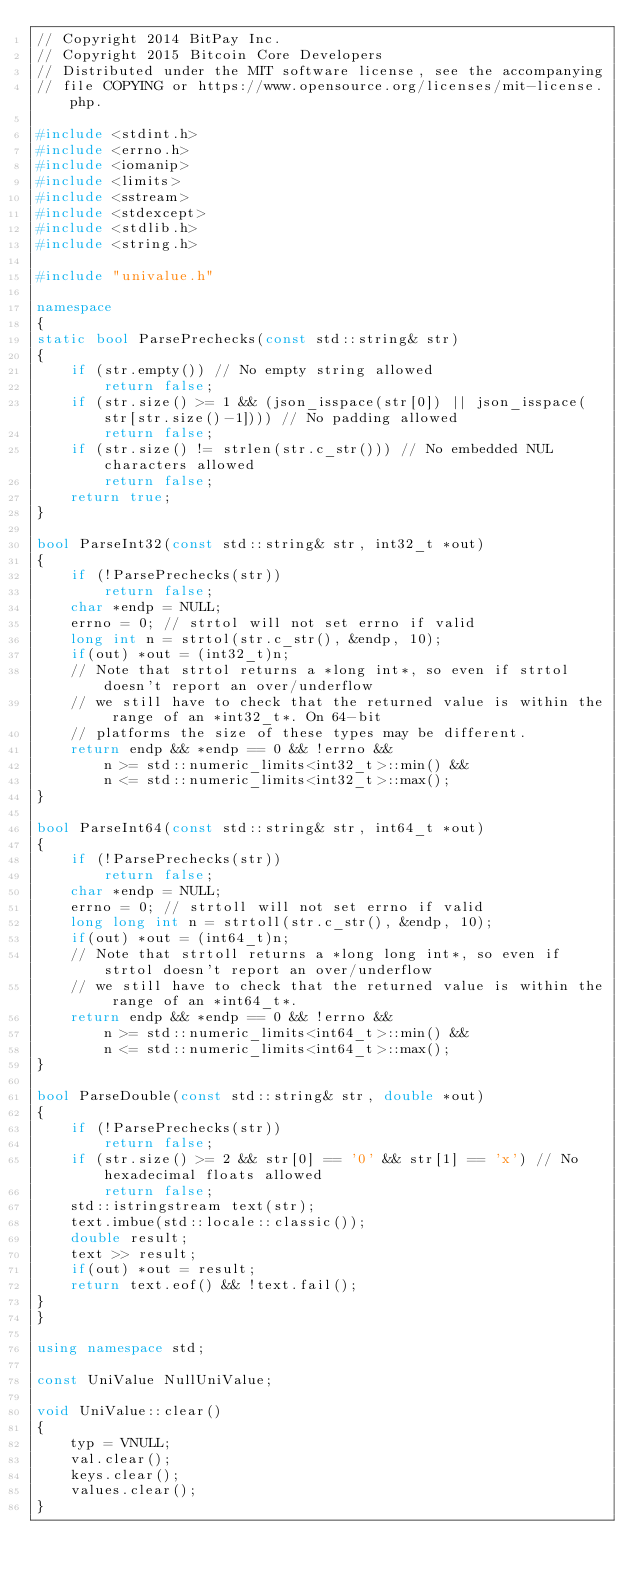<code> <loc_0><loc_0><loc_500><loc_500><_C++_>// Copyright 2014 BitPay Inc.
// Copyright 2015 Bitcoin Core Developers
// Distributed under the MIT software license, see the accompanying
// file COPYING or https://www.opensource.org/licenses/mit-license.php.

#include <stdint.h>
#include <errno.h>
#include <iomanip>
#include <limits>
#include <sstream>
#include <stdexcept>
#include <stdlib.h>
#include <string.h>

#include "univalue.h"

namespace 
{
static bool ParsePrechecks(const std::string& str)
{
    if (str.empty()) // No empty string allowed
        return false;
    if (str.size() >= 1 && (json_isspace(str[0]) || json_isspace(str[str.size()-1]))) // No padding allowed
        return false;
    if (str.size() != strlen(str.c_str())) // No embedded NUL characters allowed
        return false;
    return true;
}

bool ParseInt32(const std::string& str, int32_t *out)
{
    if (!ParsePrechecks(str))
        return false;
    char *endp = NULL;
    errno = 0; // strtol will not set errno if valid
    long int n = strtol(str.c_str(), &endp, 10);
    if(out) *out = (int32_t)n;
    // Note that strtol returns a *long int*, so even if strtol doesn't report an over/underflow
    // we still have to check that the returned value is within the range of an *int32_t*. On 64-bit
    // platforms the size of these types may be different.
    return endp && *endp == 0 && !errno &&
        n >= std::numeric_limits<int32_t>::min() &&
        n <= std::numeric_limits<int32_t>::max();
}

bool ParseInt64(const std::string& str, int64_t *out)
{
    if (!ParsePrechecks(str))
        return false;
    char *endp = NULL;
    errno = 0; // strtoll will not set errno if valid
    long long int n = strtoll(str.c_str(), &endp, 10);
    if(out) *out = (int64_t)n;
    // Note that strtoll returns a *long long int*, so even if strtol doesn't report an over/underflow
    // we still have to check that the returned value is within the range of an *int64_t*.
    return endp && *endp == 0 && !errno &&
        n >= std::numeric_limits<int64_t>::min() &&
        n <= std::numeric_limits<int64_t>::max();
}

bool ParseDouble(const std::string& str, double *out)
{
    if (!ParsePrechecks(str))
        return false;
    if (str.size() >= 2 && str[0] == '0' && str[1] == 'x') // No hexadecimal floats allowed
        return false;
    std::istringstream text(str);
    text.imbue(std::locale::classic());
    double result;
    text >> result;
    if(out) *out = result;
    return text.eof() && !text.fail();
}
}

using namespace std;

const UniValue NullUniValue;

void UniValue::clear()
{
    typ = VNULL;
    val.clear();
    keys.clear();
    values.clear();
}
</code> 